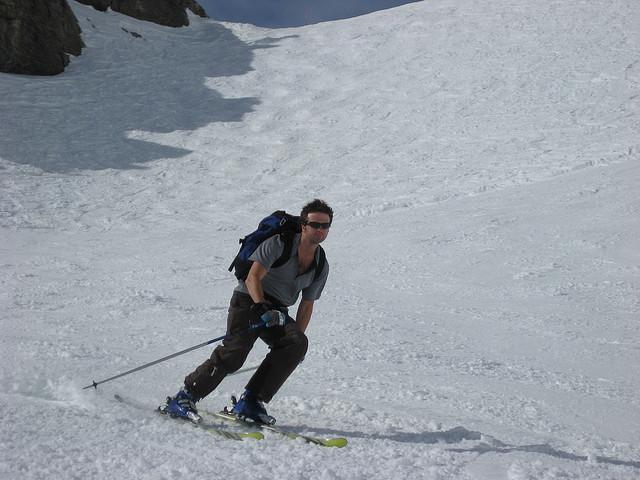What protective gear should the man wear? helmet 